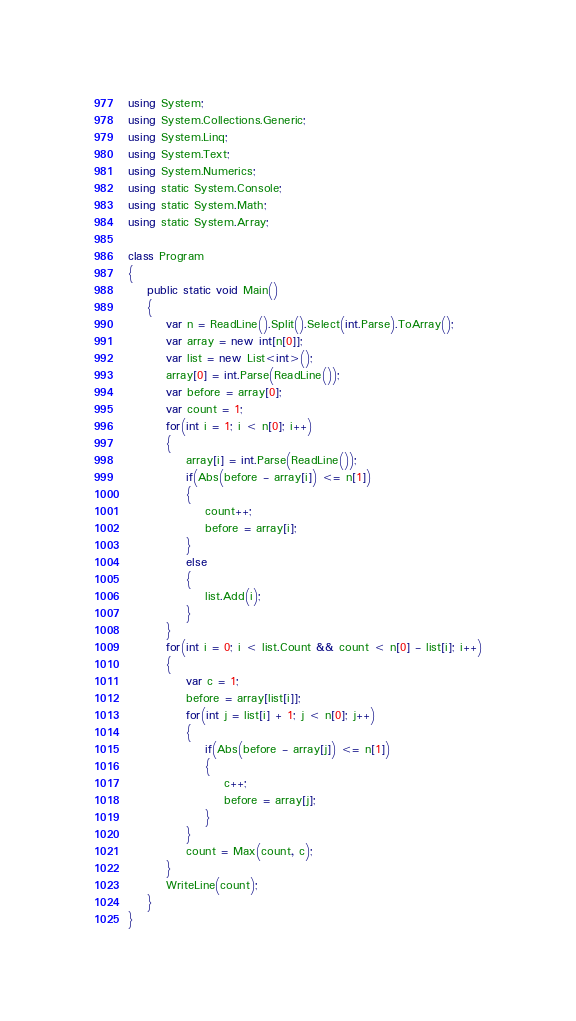Convert code to text. <code><loc_0><loc_0><loc_500><loc_500><_C#_>using System;
using System.Collections.Generic;
using System.Linq;
using System.Text;
using System.Numerics;
using static System.Console;
using static System.Math;
using static System.Array;

class Program
{
    public static void Main()
    {
        var n = ReadLine().Split().Select(int.Parse).ToArray();
        var array = new int[n[0]];
        var list = new List<int>();
        array[0] = int.Parse(ReadLine());
        var before = array[0];
        var count = 1;
        for(int i = 1; i < n[0]; i++)
        {
            array[i] = int.Parse(ReadLine());
            if(Abs(before - array[i]) <= n[1])
            {
                count++;
                before = array[i];
            }
            else
            {
                list.Add(i);
            }
        }
        for(int i = 0; i < list.Count && count < n[0] - list[i]; i++)
        {
            var c = 1;
            before = array[list[i]];
            for(int j = list[i] + 1; j < n[0]; j++)
            {
                if(Abs(before - array[j]) <= n[1])
                {
                    c++;
                    before = array[j];
                }
            }
            count = Max(count, c);
        }
        WriteLine(count);
    }
}
</code> 